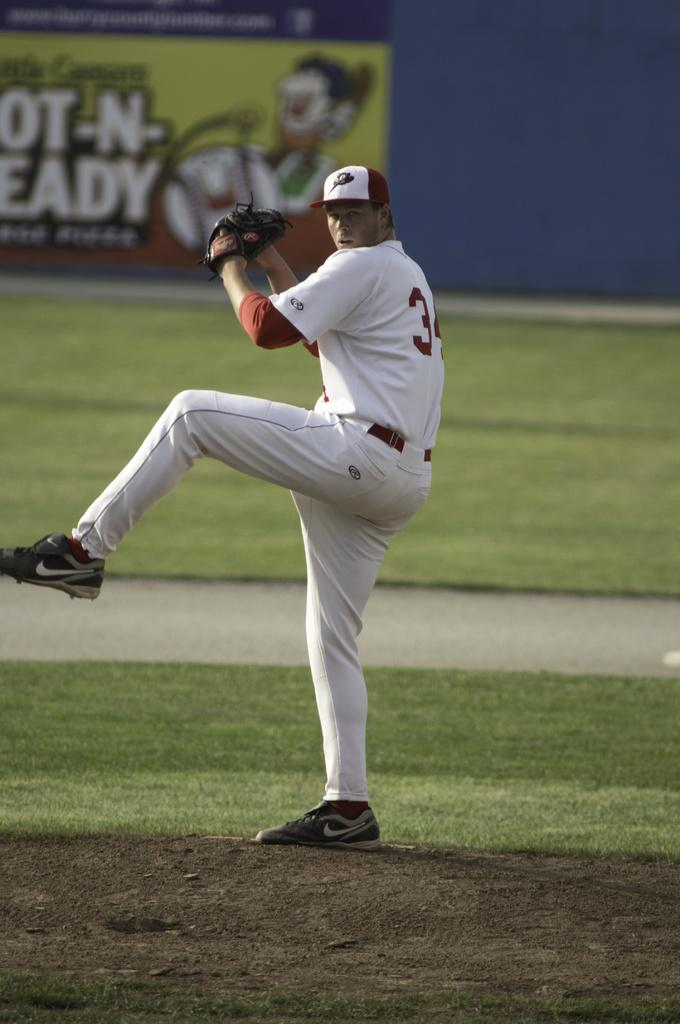Provide a one-sentence caption for the provided image. The pitcher of a baseball team with the number 3 on his uniform winds up for a pitch in front of a banner for Little Ceasars Hot-N-Ready pizzas. 